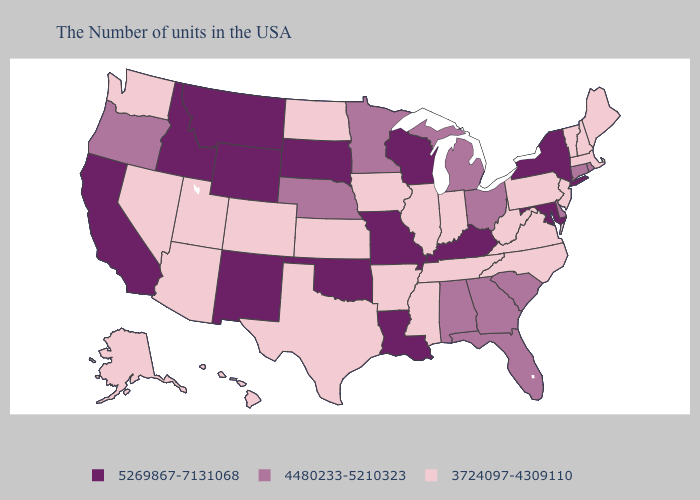Name the states that have a value in the range 3724097-4309110?
Concise answer only. Maine, Massachusetts, New Hampshire, Vermont, New Jersey, Pennsylvania, Virginia, North Carolina, West Virginia, Indiana, Tennessee, Illinois, Mississippi, Arkansas, Iowa, Kansas, Texas, North Dakota, Colorado, Utah, Arizona, Nevada, Washington, Alaska, Hawaii. What is the lowest value in states that border Missouri?
Be succinct. 3724097-4309110. Name the states that have a value in the range 3724097-4309110?
Be succinct. Maine, Massachusetts, New Hampshire, Vermont, New Jersey, Pennsylvania, Virginia, North Carolina, West Virginia, Indiana, Tennessee, Illinois, Mississippi, Arkansas, Iowa, Kansas, Texas, North Dakota, Colorado, Utah, Arizona, Nevada, Washington, Alaska, Hawaii. What is the value of New Jersey?
Concise answer only. 3724097-4309110. Does South Dakota have the lowest value in the USA?
Answer briefly. No. Among the states that border Maryland , which have the lowest value?
Keep it brief. Pennsylvania, Virginia, West Virginia. Name the states that have a value in the range 5269867-7131068?
Give a very brief answer. New York, Maryland, Kentucky, Wisconsin, Louisiana, Missouri, Oklahoma, South Dakota, Wyoming, New Mexico, Montana, Idaho, California. What is the lowest value in the Northeast?
Keep it brief. 3724097-4309110. Is the legend a continuous bar?
Quick response, please. No. Among the states that border Georgia , which have the highest value?
Keep it brief. South Carolina, Florida, Alabama. Does Alaska have a lower value than Iowa?
Short answer required. No. Name the states that have a value in the range 3724097-4309110?
Concise answer only. Maine, Massachusetts, New Hampshire, Vermont, New Jersey, Pennsylvania, Virginia, North Carolina, West Virginia, Indiana, Tennessee, Illinois, Mississippi, Arkansas, Iowa, Kansas, Texas, North Dakota, Colorado, Utah, Arizona, Nevada, Washington, Alaska, Hawaii. Name the states that have a value in the range 3724097-4309110?
Quick response, please. Maine, Massachusetts, New Hampshire, Vermont, New Jersey, Pennsylvania, Virginia, North Carolina, West Virginia, Indiana, Tennessee, Illinois, Mississippi, Arkansas, Iowa, Kansas, Texas, North Dakota, Colorado, Utah, Arizona, Nevada, Washington, Alaska, Hawaii. Does Georgia have the same value as Vermont?
Quick response, please. No. How many symbols are there in the legend?
Write a very short answer. 3. 